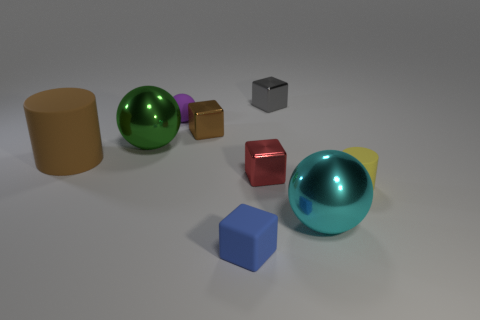Subtract all cyan cubes. Subtract all gray cylinders. How many cubes are left? 4 Add 1 cyan metallic balls. How many objects exist? 10 Subtract all balls. How many objects are left? 6 Add 8 small red shiny spheres. How many small red shiny spheres exist? 8 Subtract 0 brown spheres. How many objects are left? 9 Subtract all large brown cylinders. Subtract all large objects. How many objects are left? 5 Add 1 gray metal objects. How many gray metal objects are left? 2 